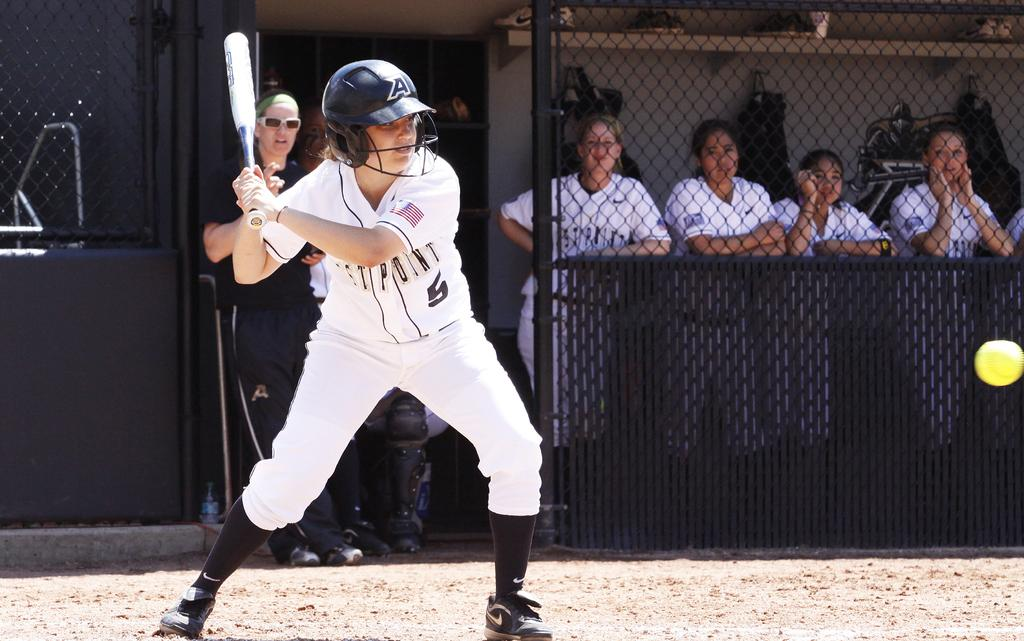<image>
Share a concise interpretation of the image provided. A person wearing number 5 from West Point is playing softball. 